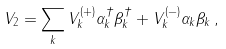<formula> <loc_0><loc_0><loc_500><loc_500>V _ { 2 } = \sum _ { k } V _ { k } ^ { ( + ) } \alpha _ { k } ^ { \dag } \beta _ { k } ^ { \dag } + V _ { k } ^ { ( - ) } \alpha _ { k } \beta _ { k } \, ,</formula> 